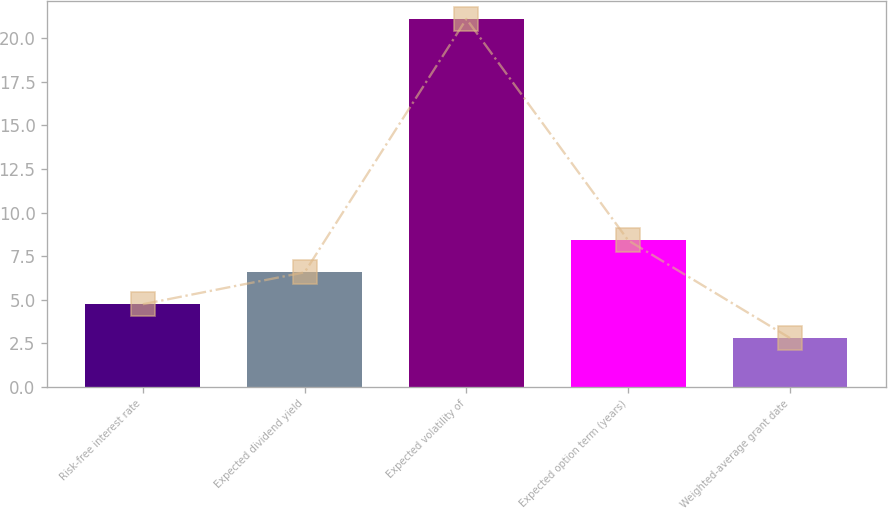Convert chart. <chart><loc_0><loc_0><loc_500><loc_500><bar_chart><fcel>Risk-free interest rate<fcel>Expected dividend yield<fcel>Expected volatility of<fcel>Expected option term (years)<fcel>Weighted-average grant date<nl><fcel>4.74<fcel>6.57<fcel>21.1<fcel>8.4<fcel>2.8<nl></chart> 